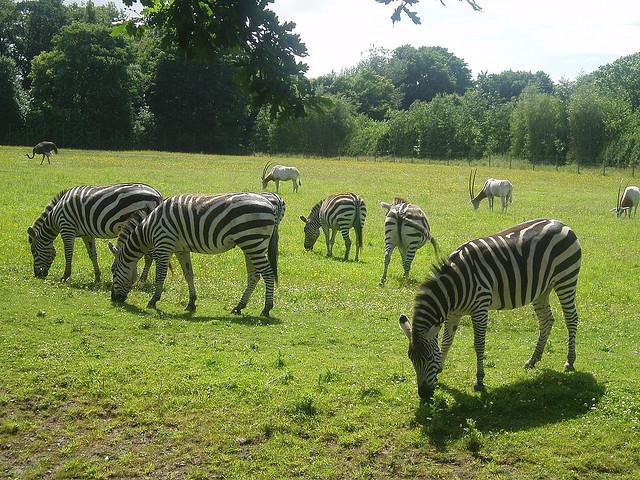Are the shadows before the zebras tree shadows?
Quick response, please. No. What are the animals eating?
Keep it brief. Grass. How many zebras are there?
Give a very brief answer. 5. How many types of animals are shown?
Quick response, please. 3. Is it raining?
Give a very brief answer. No. 